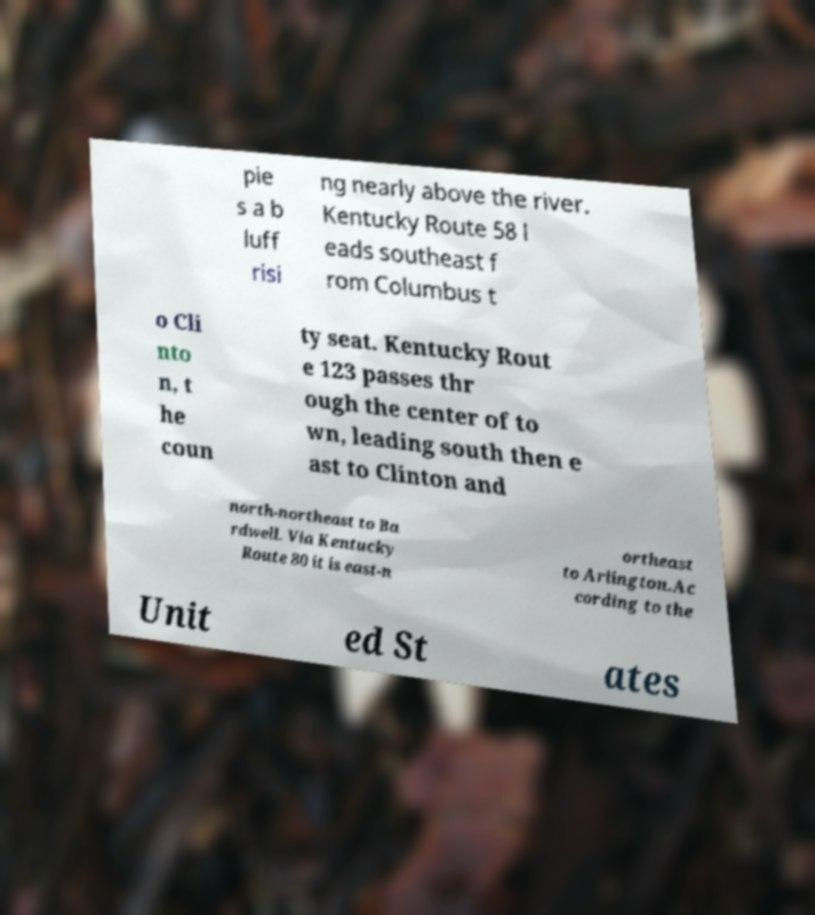Can you read and provide the text displayed in the image?This photo seems to have some interesting text. Can you extract and type it out for me? pie s a b luff risi ng nearly above the river. Kentucky Route 58 l eads southeast f rom Columbus t o Cli nto n, t he coun ty seat. Kentucky Rout e 123 passes thr ough the center of to wn, leading south then e ast to Clinton and north-northeast to Ba rdwell. Via Kentucky Route 80 it is east-n ortheast to Arlington.Ac cording to the Unit ed St ates 